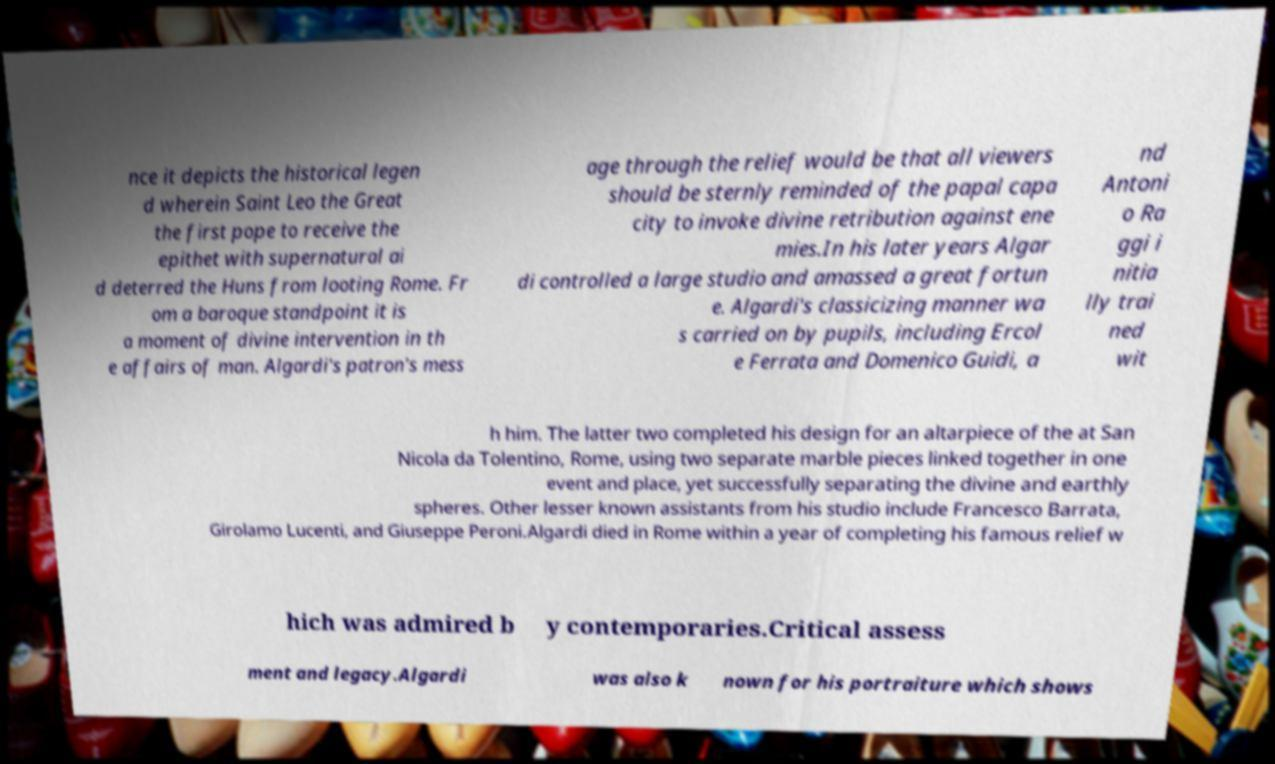I need the written content from this picture converted into text. Can you do that? nce it depicts the historical legen d wherein Saint Leo the Great the first pope to receive the epithet with supernatural ai d deterred the Huns from looting Rome. Fr om a baroque standpoint it is a moment of divine intervention in th e affairs of man. Algardi's patron's mess age through the relief would be that all viewers should be sternly reminded of the papal capa city to invoke divine retribution against ene mies.In his later years Algar di controlled a large studio and amassed a great fortun e. Algardi's classicizing manner wa s carried on by pupils, including Ercol e Ferrata and Domenico Guidi, a nd Antoni o Ra ggi i nitia lly trai ned wit h him. The latter two completed his design for an altarpiece of the at San Nicola da Tolentino, Rome, using two separate marble pieces linked together in one event and place, yet successfully separating the divine and earthly spheres. Other lesser known assistants from his studio include Francesco Barrata, Girolamo Lucenti, and Giuseppe Peroni.Algardi died in Rome within a year of completing his famous relief w hich was admired b y contemporaries.Critical assess ment and legacy.Algardi was also k nown for his portraiture which shows 